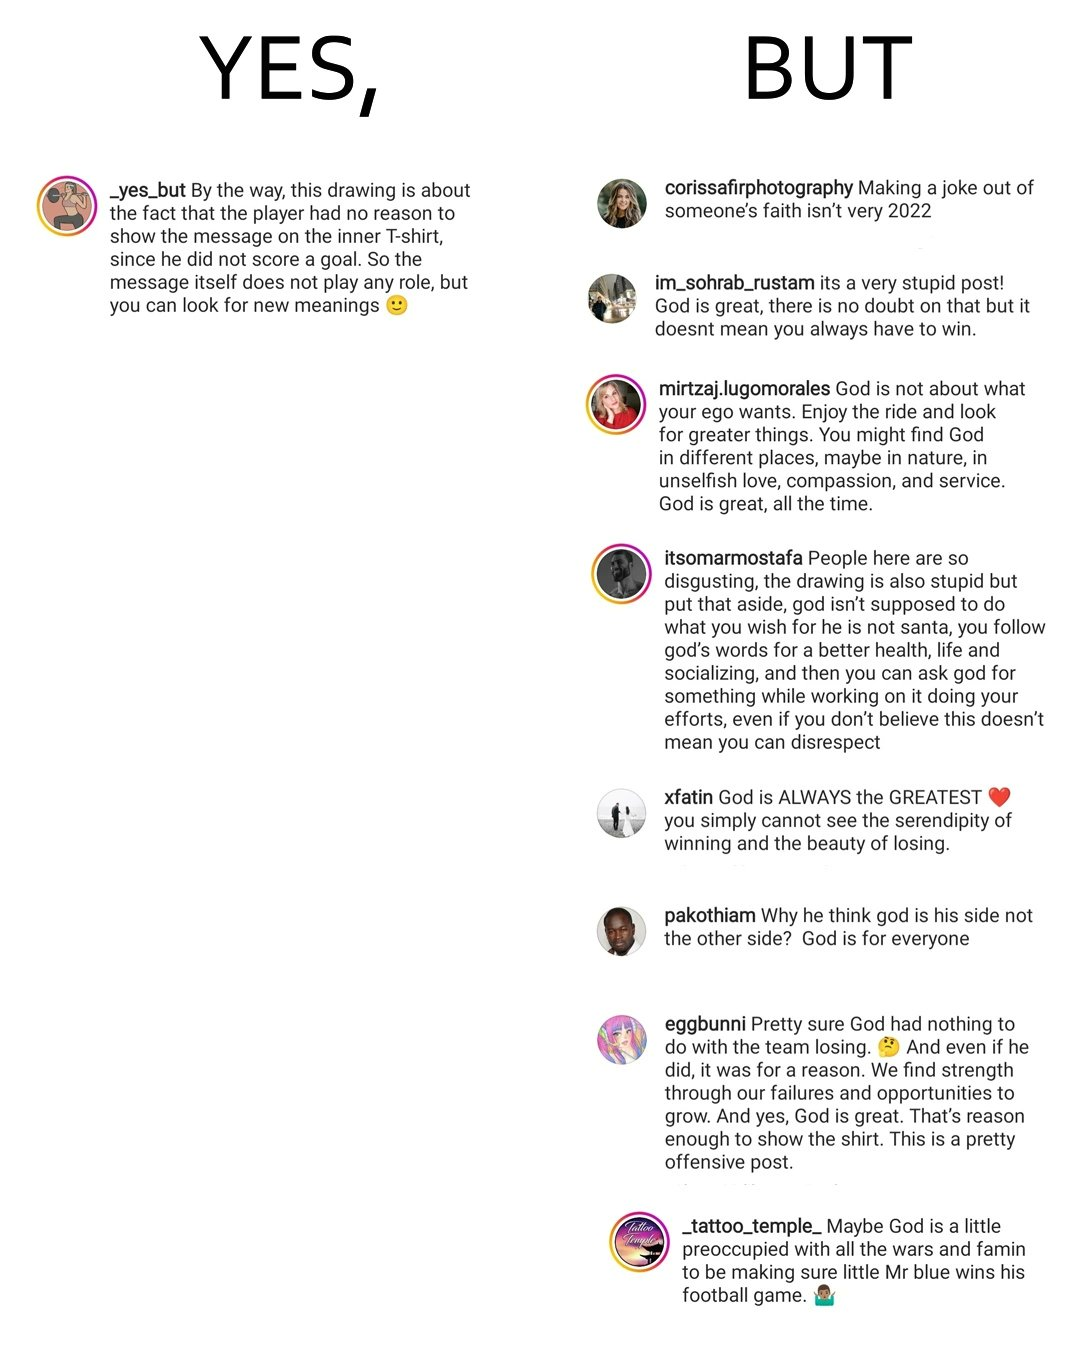Describe the content of this image. The image is ironic, because the person in the first image is trying to explain about some content posted by it and in the second image the people in the comment section has misinterpreted the posted and are declaring or criticising it as an offensive joke rather than knowing the real meaning or logic behind the post 